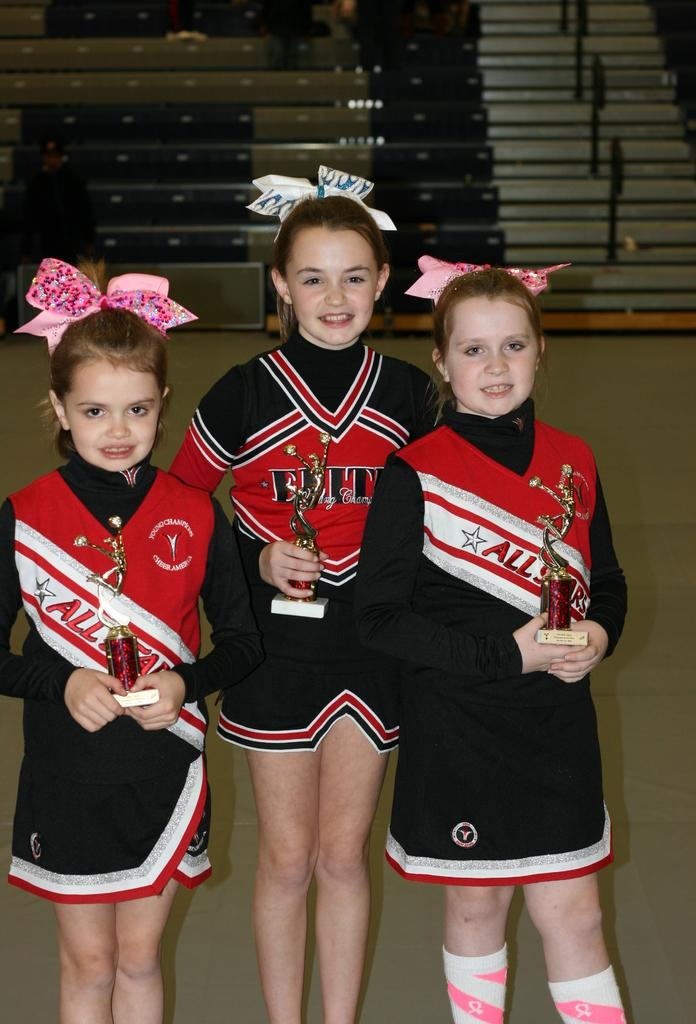<image>
Provide a brief description of the given image. Three cheerleaders hold trophies while wearing All Star uniforms together. 